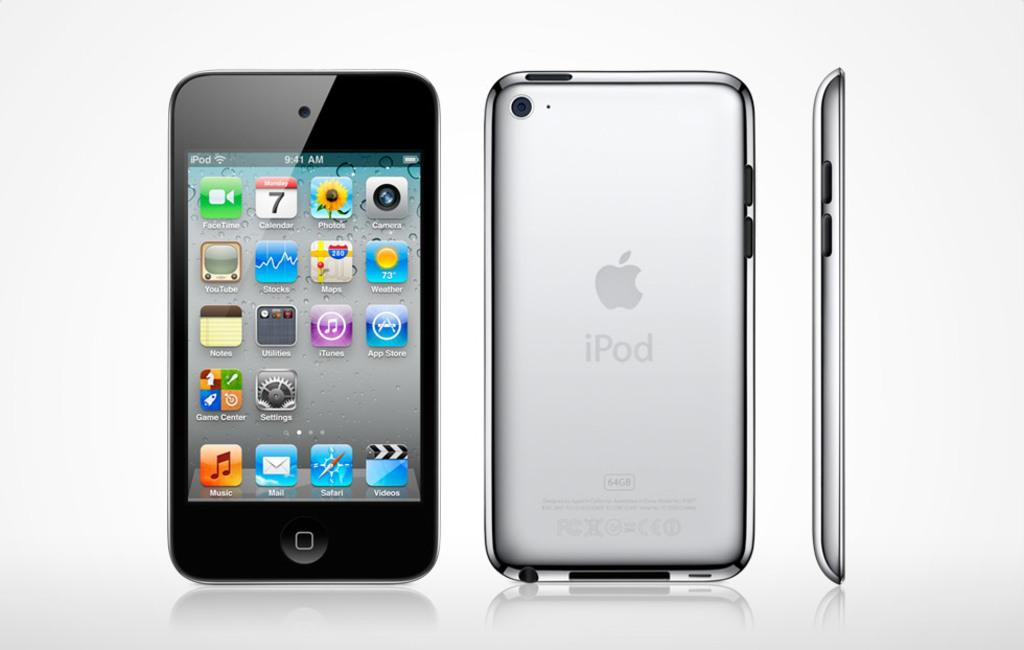<image>
Provide a brief description of the given image. Phone screen that says the word iPod on the top. 